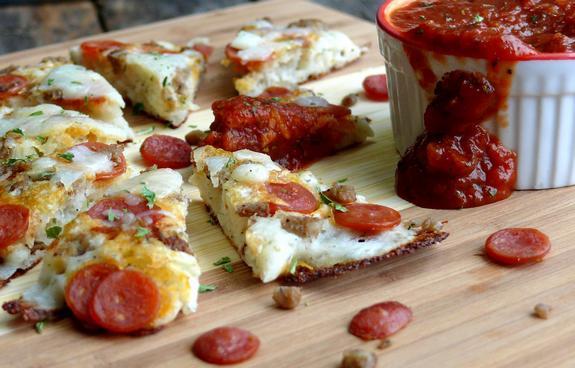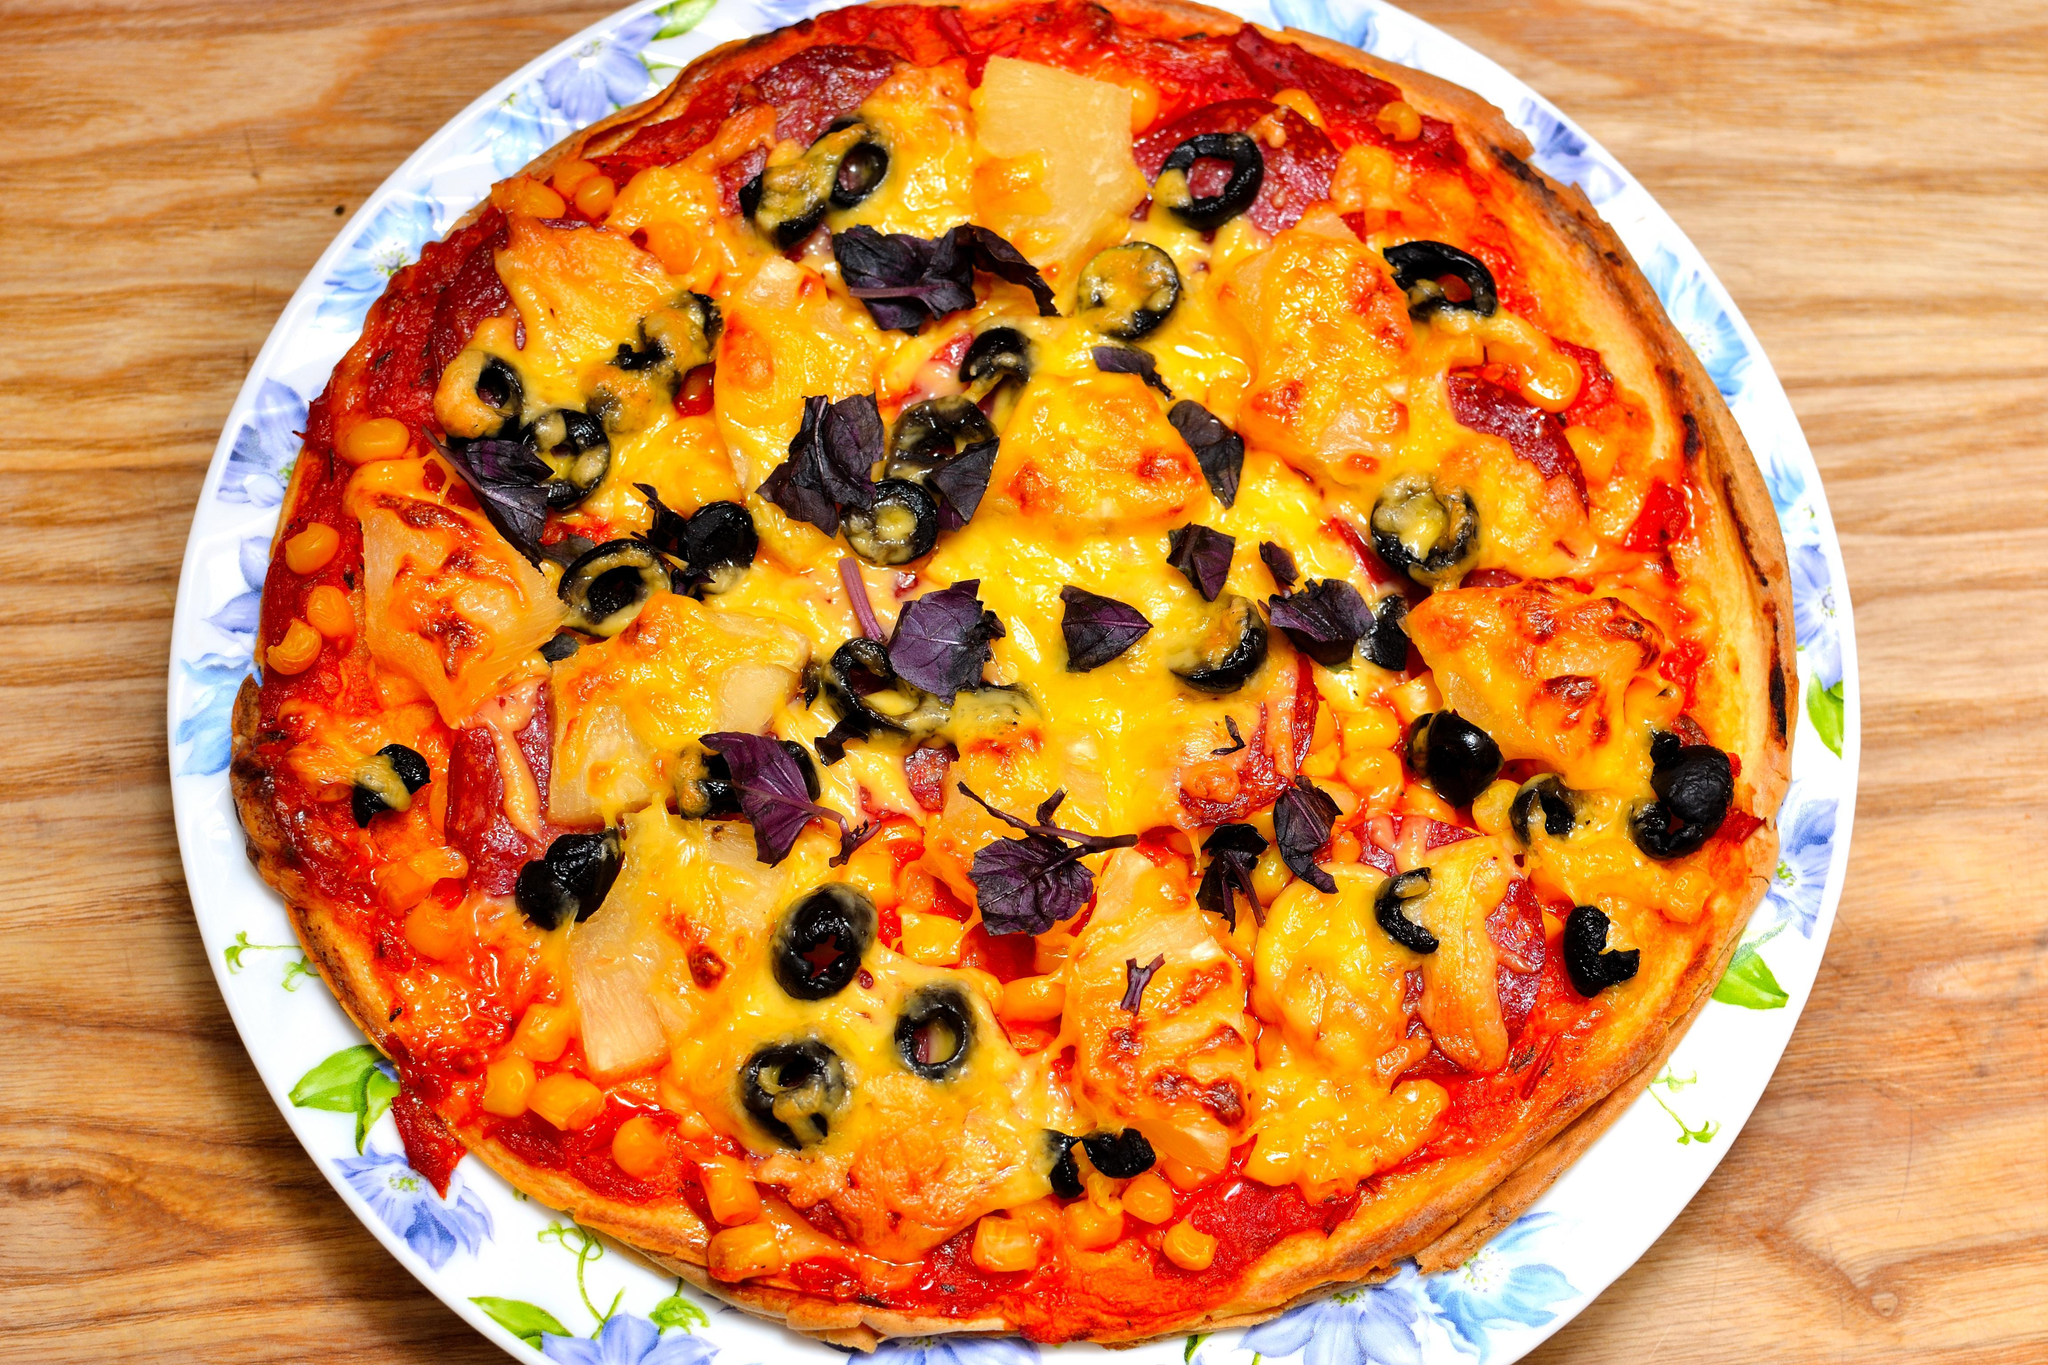The first image is the image on the left, the second image is the image on the right. Examine the images to the left and right. Is the description "In the left image, there is more than one individual pizza." accurate? Answer yes or no. No. The first image is the image on the left, the second image is the image on the right. Considering the images on both sides, is "There is pepperoni on the table." valid? Answer yes or no. Yes. 